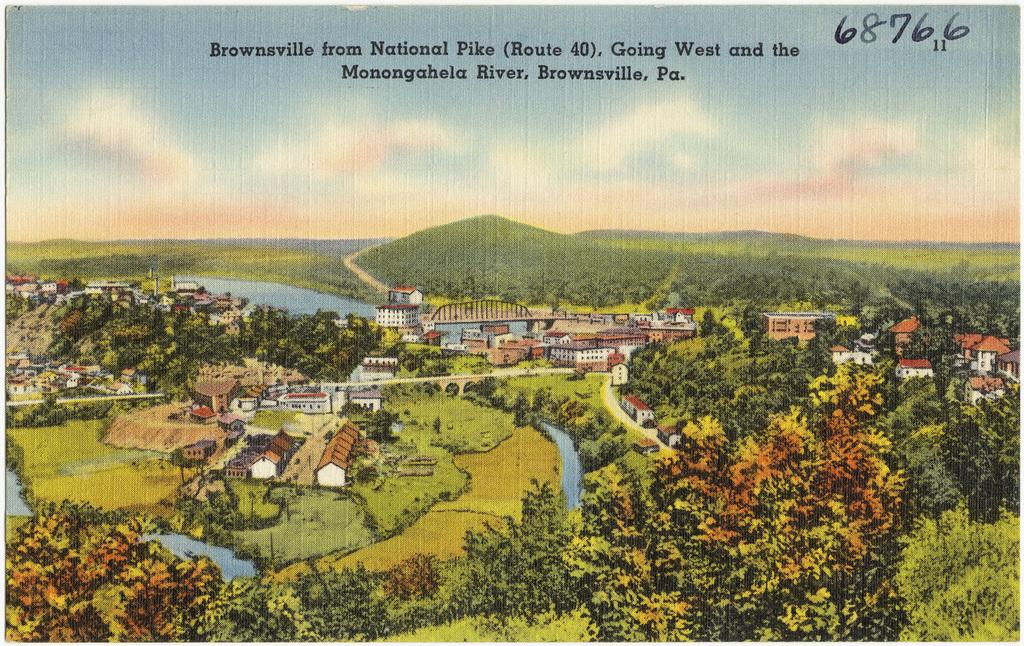<image>
Write a terse but informative summary of the picture. A painting of a small town with a river running through it with the numbers 68766 on the top right. 